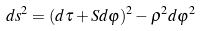<formula> <loc_0><loc_0><loc_500><loc_500>d s ^ { 2 } = ( d \tau + S d \varphi ) ^ { 2 } - \rho ^ { 2 } d \varphi ^ { 2 }</formula> 